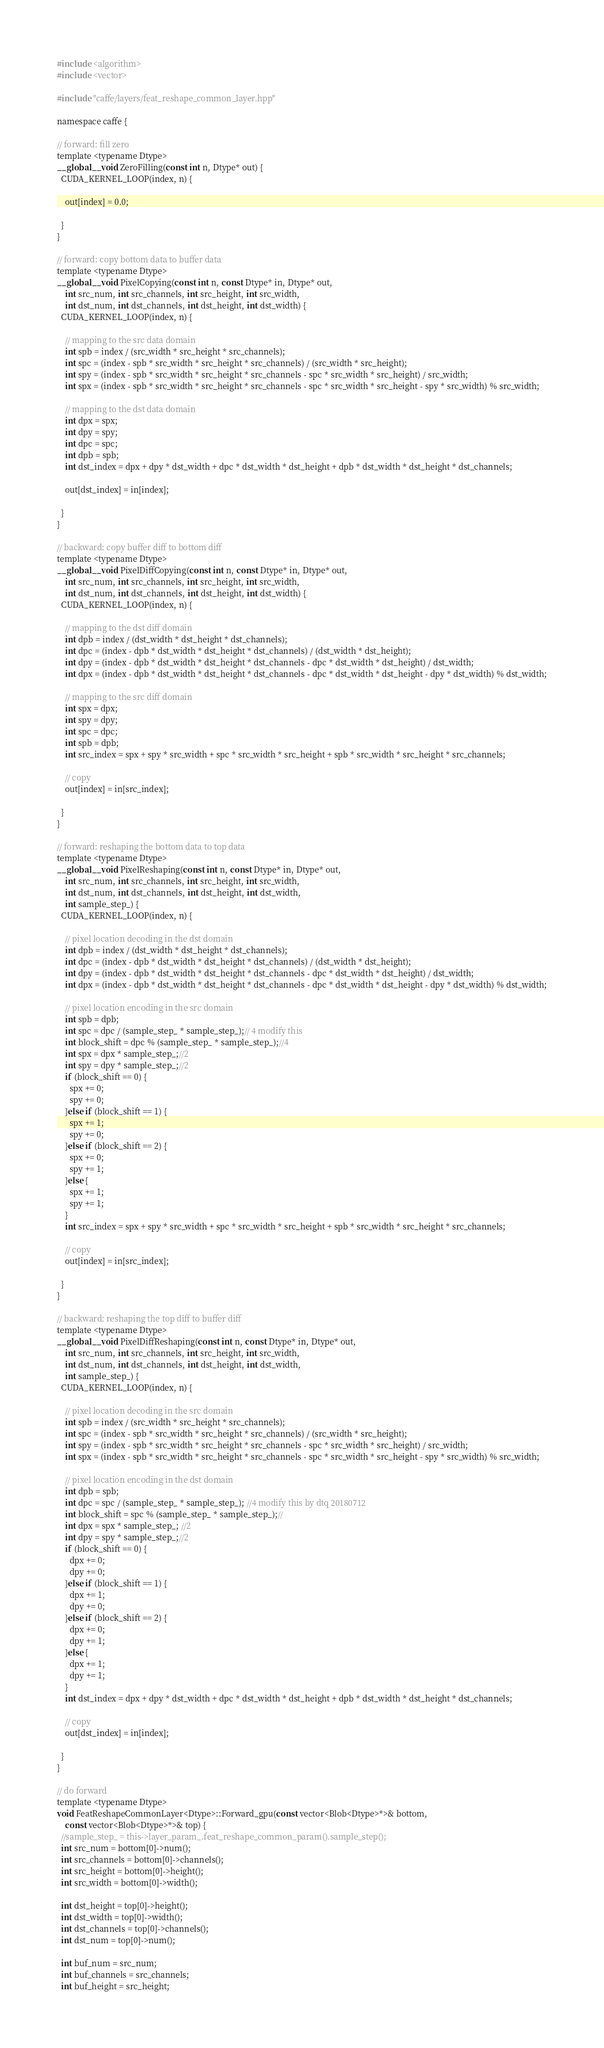Convert code to text. <code><loc_0><loc_0><loc_500><loc_500><_Cuda_>#include <algorithm>
#include <vector>

#include "caffe/layers/feat_reshape_common_layer.hpp"

namespace caffe {

// forward: fill zero
template <typename Dtype>
__global__ void ZeroFilling(const int n, Dtype* out) {
  CUDA_KERNEL_LOOP(index, n) {

    out[index] = 0.0;

  }
}

// forward: copy bottom data to buffer data
template <typename Dtype>
__global__ void PixelCopying(const int n, const Dtype* in, Dtype* out,
    int src_num, int src_channels, int src_height, int src_width,
    int dst_num, int dst_channels, int dst_height, int dst_width) {
  CUDA_KERNEL_LOOP(index, n) {

    // mapping to the src data domain
    int spb = index / (src_width * src_height * src_channels);
    int spc = (index - spb * src_width * src_height * src_channels) / (src_width * src_height);
    int spy = (index - spb * src_width * src_height * src_channels - spc * src_width * src_height) / src_width;
    int spx = (index - spb * src_width * src_height * src_channels - spc * src_width * src_height - spy * src_width) % src_width;

    // mapping to the dst data domain
    int dpx = spx;
    int dpy = spy;
    int dpc = spc;
    int dpb = spb;
    int dst_index = dpx + dpy * dst_width + dpc * dst_width * dst_height + dpb * dst_width * dst_height * dst_channels;
    
    out[dst_index] = in[index];

  }
}

// backward: copy buffer diff to bottom diff
template <typename Dtype>
__global__ void PixelDiffCopying(const int n, const Dtype* in, Dtype* out,
    int src_num, int src_channels, int src_height, int src_width,
    int dst_num, int dst_channels, int dst_height, int dst_width) {
  CUDA_KERNEL_LOOP(index, n) {

    // mapping to the dst diff domain
    int dpb = index / (dst_width * dst_height * dst_channels);
    int dpc = (index - dpb * dst_width * dst_height * dst_channels) / (dst_width * dst_height);
    int dpy = (index - dpb * dst_width * dst_height * dst_channels - dpc * dst_width * dst_height) / dst_width;
    int dpx = (index - dpb * dst_width * dst_height * dst_channels - dpc * dst_width * dst_height - dpy * dst_width) % dst_width;

    // mapping to the src diff domain
    int spx = dpx;
    int spy = dpy;
    int spc = dpc;
    int spb = dpb;
    int src_index = spx + spy * src_width + spc * src_width * src_height + spb * src_width * src_height * src_channels;
    
    // copy
    out[index] = in[src_index];

  }
}

// forward: reshaping the bottom data to top data
template <typename Dtype>
__global__ void PixelReshaping(const int n, const Dtype* in, Dtype* out,
    int src_num, int src_channels, int src_height, int src_width, 
    int dst_num, int dst_channels, int dst_height, int dst_width,
    int sample_step_) {
  CUDA_KERNEL_LOOP(index, n) {
    
    // pixel location decoding in the dst domain
    int dpb = index / (dst_width * dst_height * dst_channels);
    int dpc = (index - dpb * dst_width * dst_height * dst_channels) / (dst_width * dst_height);
    int dpy = (index - dpb * dst_width * dst_height * dst_channels - dpc * dst_width * dst_height) / dst_width;
    int dpx = (index - dpb * dst_width * dst_height * dst_channels - dpc * dst_width * dst_height - dpy * dst_width) % dst_width;

    // pixel location encoding in the src domain
    int spb = dpb;
    int spc = dpc / (sample_step_ * sample_step_);// 4 modify this 
    int block_shift = dpc % (sample_step_ * sample_step_);//4
    int spx = dpx * sample_step_;//2
    int spy = dpy * sample_step_;//2
    if (block_shift == 0) {
      spx += 0;
      spy += 0;
    }else if (block_shift == 1) {
      spx += 1;
      spy += 0;
    }else if (block_shift == 2) {
      spx += 0;
      spy += 1;
    }else {
      spx += 1;
      spy += 1;
    }
    int src_index = spx + spy * src_width + spc * src_width * src_height + spb * src_width * src_height * src_channels; 
    
    // copy
    out[index] = in[src_index];

  }
}

// backward: reshaping the top diff to buffer diff
template <typename Dtype>
__global__ void PixelDiffReshaping(const int n, const Dtype* in, Dtype* out,
    int src_num, int src_channels, int src_height, int src_width,
    int dst_num, int dst_channels, int dst_height, int dst_width,
    int sample_step_) {
  CUDA_KERNEL_LOOP(index, n) {

    // pixel location decoding in the src domain
    int spb = index / (src_width * src_height * src_channels);
    int spc = (index - spb * src_width * src_height * src_channels) / (src_width * src_height);
    int spy = (index - spb * src_width * src_height * src_channels - spc * src_width * src_height) / src_width;
    int spx = (index - spb * src_width * src_height * src_channels - spc * src_width * src_height - spy * src_width) % src_width;
    
    // pixel location encoding in the dst domain
    int dpb = spb;
    int dpc = spc / (sample_step_ * sample_step_); //4 modify this by dtq 20180712
    int block_shift = spc % (sample_step_ * sample_step_);//
    int dpx = spx * sample_step_; //2
    int dpy = spy * sample_step_;//2
    if (block_shift == 0) {
      dpx += 0;
      dpy += 0;
    }else if (block_shift == 1) {
      dpx += 1;
      dpy += 0;
    }else if (block_shift == 2) {
      dpx += 0;
      dpy += 1;
    }else {
      dpx += 1;
      dpy += 1;
    }
    int dst_index = dpx + dpy * dst_width + dpc * dst_width * dst_height + dpb * dst_width * dst_height * dst_channels;

    // copy
    out[dst_index] = in[index];

  }
}

// do forward
template <typename Dtype>
void FeatReshapeCommonLayer<Dtype>::Forward_gpu(const vector<Blob<Dtype>*>& bottom,
    const vector<Blob<Dtype>*>& top) {
  //sample_step_ = this->layer_param_.feat_reshape_common_param().sample_step();
  int src_num = bottom[0]->num();
  int src_channels = bottom[0]->channels();
  int src_height = bottom[0]->height();
  int src_width = bottom[0]->width();

  int dst_height = top[0]->height();
  int dst_width = top[0]->width();
  int dst_channels = top[0]->channels();
  int dst_num = top[0]->num();

  int buf_num = src_num;
  int buf_channels = src_channels;
  int buf_height = src_height;</code> 